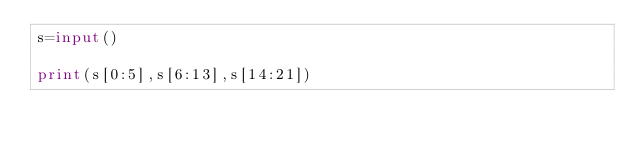Convert code to text. <code><loc_0><loc_0><loc_500><loc_500><_Python_>s=input()

print(s[0:5],s[6:13],s[14:21])</code> 